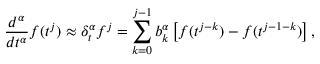Convert formula to latex. <formula><loc_0><loc_0><loc_500><loc_500>\frac { d ^ { \alpha } } { d t ^ { \alpha } } f ( t ^ { j } ) \approx \delta _ { t } ^ { \alpha } f ^ { j } = \sum _ { k = 0 } ^ { j - 1 } b _ { k } ^ { \alpha } \left [ f ( t ^ { j - k } ) - f ( t ^ { j - 1 - k } ) \right ] ,</formula> 